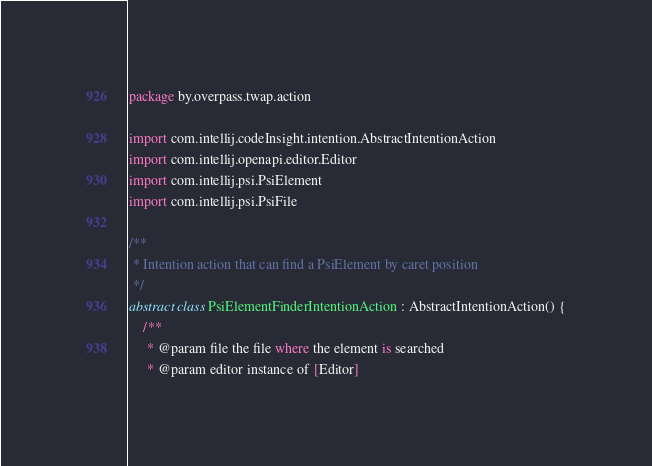Convert code to text. <code><loc_0><loc_0><loc_500><loc_500><_Kotlin_>package by.overpass.twap.action

import com.intellij.codeInsight.intention.AbstractIntentionAction
import com.intellij.openapi.editor.Editor
import com.intellij.psi.PsiElement
import com.intellij.psi.PsiFile

/**
 * Intention action that can find a PsiElement by caret position
 */
abstract class PsiElementFinderIntentionAction : AbstractIntentionAction() {
    /**
     * @param file the file where the element is searched
     * @param editor instance of [Editor]</code> 